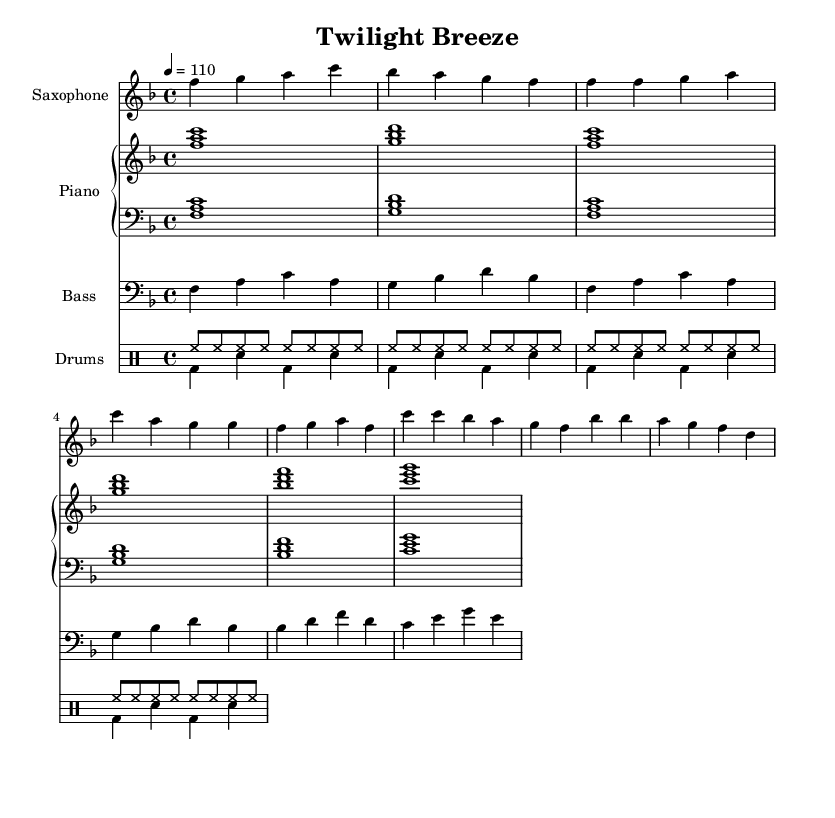What is the key signature of this music? The key signature is F major, which has one flat (B flat). You can identify the key signature by looking at the clef and the symbol placed right after it at the beginning of the staff.
Answer: F major What is the time signature of the piece? The time signature is 4/4, as indicated at the beginning of the music. It shows that there are four beats per measure and the quarter note gets one beat.
Answer: 4/4 What is the tempo marking of the music? The tempo is marked as quarter note equals 110, which indicates how fast the piece should be played. This can be found next to the time signature at the beginning of the score.
Answer: 110 How many measures are in the chorus section? The chorus section consists of four measures, which can be determined by counting the measures indicated in the chorus part of the score.
Answer: 4 What instrument is playing the main melody? The main melody is played by the saxophone, as indicated by the instrument label on the staff for the saxophone part at the top of the score.
Answer: Saxophone What rhythmic pattern is used for the drums? The rhythmic pattern for the drums consists of an alternating pattern between hi-hat and bass drum beats in distinct subdivisions throughout the piece. This is established through the drum notation specifically in the drummode sections of the score.
Answer: Alternating pattern Which instrument plays the bass line? The bass line is played by the bass, identified by the corresponding staff labeled as "Bass" at the beginning of the score.
Answer: Bass 